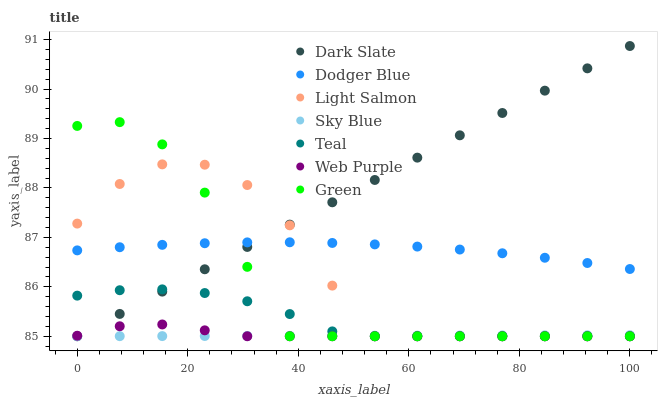Does Sky Blue have the minimum area under the curve?
Answer yes or no. Yes. Does Dark Slate have the maximum area under the curve?
Answer yes or no. Yes. Does Green have the minimum area under the curve?
Answer yes or no. No. Does Green have the maximum area under the curve?
Answer yes or no. No. Is Sky Blue the smoothest?
Answer yes or no. Yes. Is Light Salmon the roughest?
Answer yes or no. Yes. Is Green the smoothest?
Answer yes or no. No. Is Green the roughest?
Answer yes or no. No. Does Light Salmon have the lowest value?
Answer yes or no. Yes. Does Dodger Blue have the lowest value?
Answer yes or no. No. Does Dark Slate have the highest value?
Answer yes or no. Yes. Does Green have the highest value?
Answer yes or no. No. Is Sky Blue less than Dodger Blue?
Answer yes or no. Yes. Is Dodger Blue greater than Sky Blue?
Answer yes or no. Yes. Does Dark Slate intersect Green?
Answer yes or no. Yes. Is Dark Slate less than Green?
Answer yes or no. No. Is Dark Slate greater than Green?
Answer yes or no. No. Does Sky Blue intersect Dodger Blue?
Answer yes or no. No. 